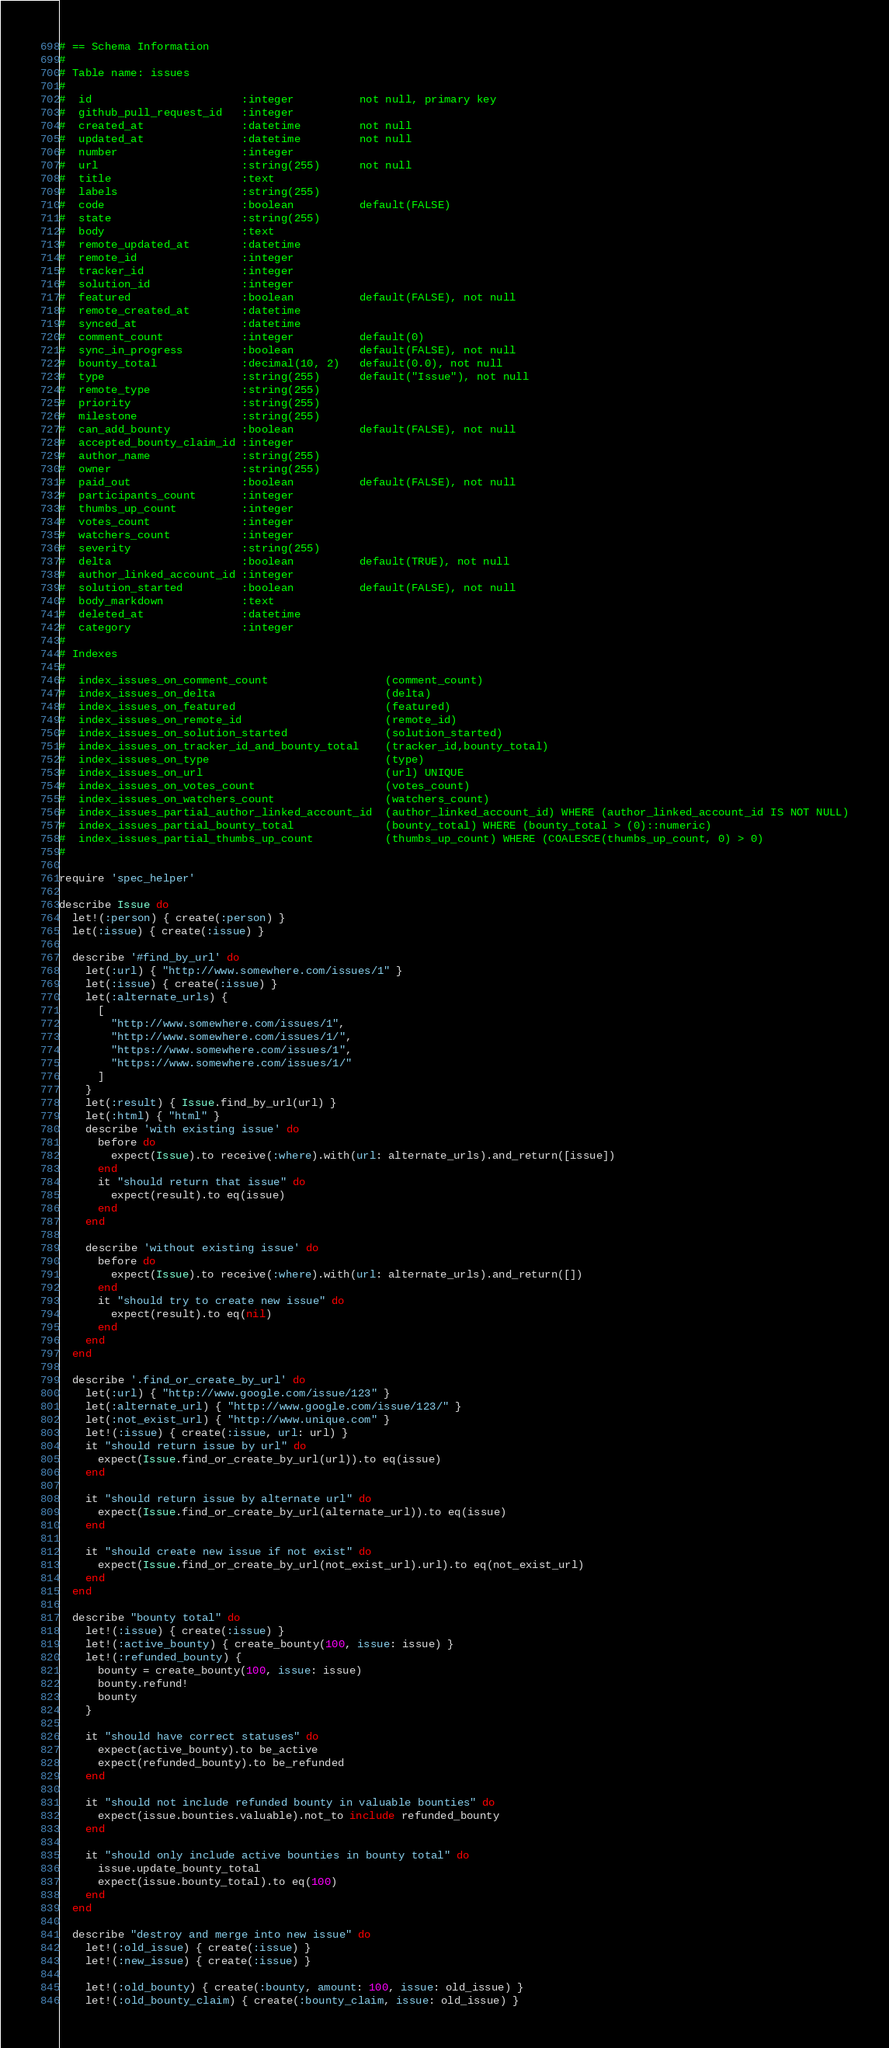Convert code to text. <code><loc_0><loc_0><loc_500><loc_500><_Ruby_># == Schema Information
#
# Table name: issues
#
#  id                       :integer          not null, primary key
#  github_pull_request_id   :integer
#  created_at               :datetime         not null
#  updated_at               :datetime         not null
#  number                   :integer
#  url                      :string(255)      not null
#  title                    :text
#  labels                   :string(255)
#  code                     :boolean          default(FALSE)
#  state                    :string(255)
#  body                     :text
#  remote_updated_at        :datetime
#  remote_id                :integer
#  tracker_id               :integer
#  solution_id              :integer
#  featured                 :boolean          default(FALSE), not null
#  remote_created_at        :datetime
#  synced_at                :datetime
#  comment_count            :integer          default(0)
#  sync_in_progress         :boolean          default(FALSE), not null
#  bounty_total             :decimal(10, 2)   default(0.0), not null
#  type                     :string(255)      default("Issue"), not null
#  remote_type              :string(255)
#  priority                 :string(255)
#  milestone                :string(255)
#  can_add_bounty           :boolean          default(FALSE), not null
#  accepted_bounty_claim_id :integer
#  author_name              :string(255)
#  owner                    :string(255)
#  paid_out                 :boolean          default(FALSE), not null
#  participants_count       :integer
#  thumbs_up_count          :integer
#  votes_count              :integer
#  watchers_count           :integer
#  severity                 :string(255)
#  delta                    :boolean          default(TRUE), not null
#  author_linked_account_id :integer
#  solution_started         :boolean          default(FALSE), not null
#  body_markdown            :text
#  deleted_at               :datetime
#  category                 :integer
#
# Indexes
#
#  index_issues_on_comment_count                  (comment_count)
#  index_issues_on_delta                          (delta)
#  index_issues_on_featured                       (featured)
#  index_issues_on_remote_id                      (remote_id)
#  index_issues_on_solution_started               (solution_started)
#  index_issues_on_tracker_id_and_bounty_total    (tracker_id,bounty_total)
#  index_issues_on_type                           (type)
#  index_issues_on_url                            (url) UNIQUE
#  index_issues_on_votes_count                    (votes_count)
#  index_issues_on_watchers_count                 (watchers_count)
#  index_issues_partial_author_linked_account_id  (author_linked_account_id) WHERE (author_linked_account_id IS NOT NULL)
#  index_issues_partial_bounty_total              (bounty_total) WHERE (bounty_total > (0)::numeric)
#  index_issues_partial_thumbs_up_count           (thumbs_up_count) WHERE (COALESCE(thumbs_up_count, 0) > 0)
#

require 'spec_helper'

describe Issue do
  let!(:person) { create(:person) }
  let(:issue) { create(:issue) }

  describe '#find_by_url' do
    let(:url) { "http://www.somewhere.com/issues/1" }
    let(:issue) { create(:issue) }
    let(:alternate_urls) {
      [
        "http://www.somewhere.com/issues/1",
        "http://www.somewhere.com/issues/1/",
        "https://www.somewhere.com/issues/1",
        "https://www.somewhere.com/issues/1/"
      ]
    }
    let(:result) { Issue.find_by_url(url) }
    let(:html) { "html" }
    describe 'with existing issue' do
      before do
        expect(Issue).to receive(:where).with(url: alternate_urls).and_return([issue])
      end
      it "should return that issue" do
        expect(result).to eq(issue)
      end
    end

    describe 'without existing issue' do
      before do
        expect(Issue).to receive(:where).with(url: alternate_urls).and_return([])
      end
      it "should try to create new issue" do
        expect(result).to eq(nil)
      end
    end
  end

  describe '.find_or_create_by_url' do
    let(:url) { "http://www.google.com/issue/123" }
    let(:alternate_url) { "http://www.google.com/issue/123/" }
    let(:not_exist_url) { "http://www.unique.com" }
    let!(:issue) { create(:issue, url: url) }
    it "should return issue by url" do
      expect(Issue.find_or_create_by_url(url)).to eq(issue)
    end

    it "should return issue by alternate url" do
      expect(Issue.find_or_create_by_url(alternate_url)).to eq(issue)
    end

    it "should create new issue if not exist" do
      expect(Issue.find_or_create_by_url(not_exist_url).url).to eq(not_exist_url)
    end
  end

  describe "bounty total" do
    let!(:issue) { create(:issue) }
    let!(:active_bounty) { create_bounty(100, issue: issue) }
    let!(:refunded_bounty) {
      bounty = create_bounty(100, issue: issue)
      bounty.refund!
      bounty
    }

    it "should have correct statuses" do
      expect(active_bounty).to be_active
      expect(refunded_bounty).to be_refunded
    end

    it "should not include refunded bounty in valuable bounties" do
      expect(issue.bounties.valuable).not_to include refunded_bounty
    end

    it "should only include active bounties in bounty total" do
      issue.update_bounty_total
      expect(issue.bounty_total).to eq(100)
    end
  end

  describe "destroy and merge into new issue" do
    let!(:old_issue) { create(:issue) }
    let!(:new_issue) { create(:issue) }

    let!(:old_bounty) { create(:bounty, amount: 100, issue: old_issue) }
    let!(:old_bounty_claim) { create(:bounty_claim, issue: old_issue) }
</code> 